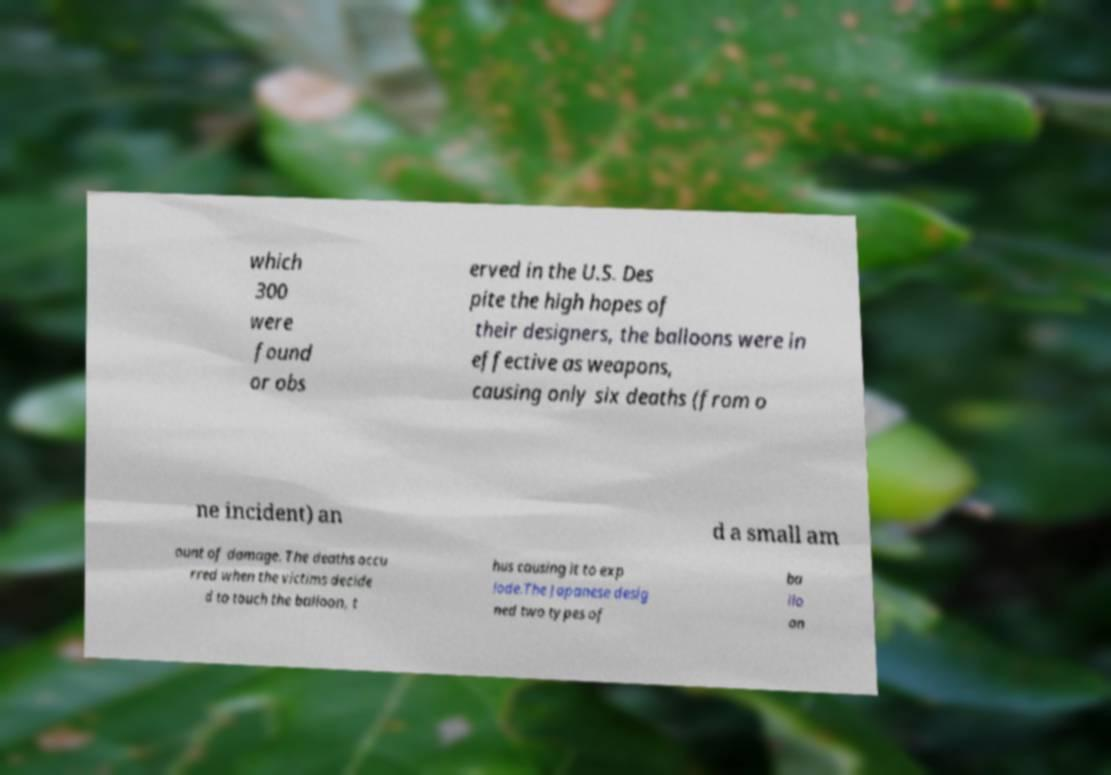What messages or text are displayed in this image? I need them in a readable, typed format. which 300 were found or obs erved in the U.S. Des pite the high hopes of their designers, the balloons were in effective as weapons, causing only six deaths (from o ne incident) an d a small am ount of damage. The deaths occu rred when the victims decide d to touch the balloon, t hus causing it to exp lode.The Japanese desig ned two types of ba llo on 